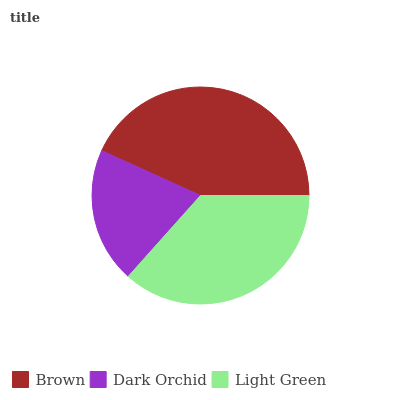Is Dark Orchid the minimum?
Answer yes or no. Yes. Is Brown the maximum?
Answer yes or no. Yes. Is Light Green the minimum?
Answer yes or no. No. Is Light Green the maximum?
Answer yes or no. No. Is Light Green greater than Dark Orchid?
Answer yes or no. Yes. Is Dark Orchid less than Light Green?
Answer yes or no. Yes. Is Dark Orchid greater than Light Green?
Answer yes or no. No. Is Light Green less than Dark Orchid?
Answer yes or no. No. Is Light Green the high median?
Answer yes or no. Yes. Is Light Green the low median?
Answer yes or no. Yes. Is Brown the high median?
Answer yes or no. No. Is Brown the low median?
Answer yes or no. No. 